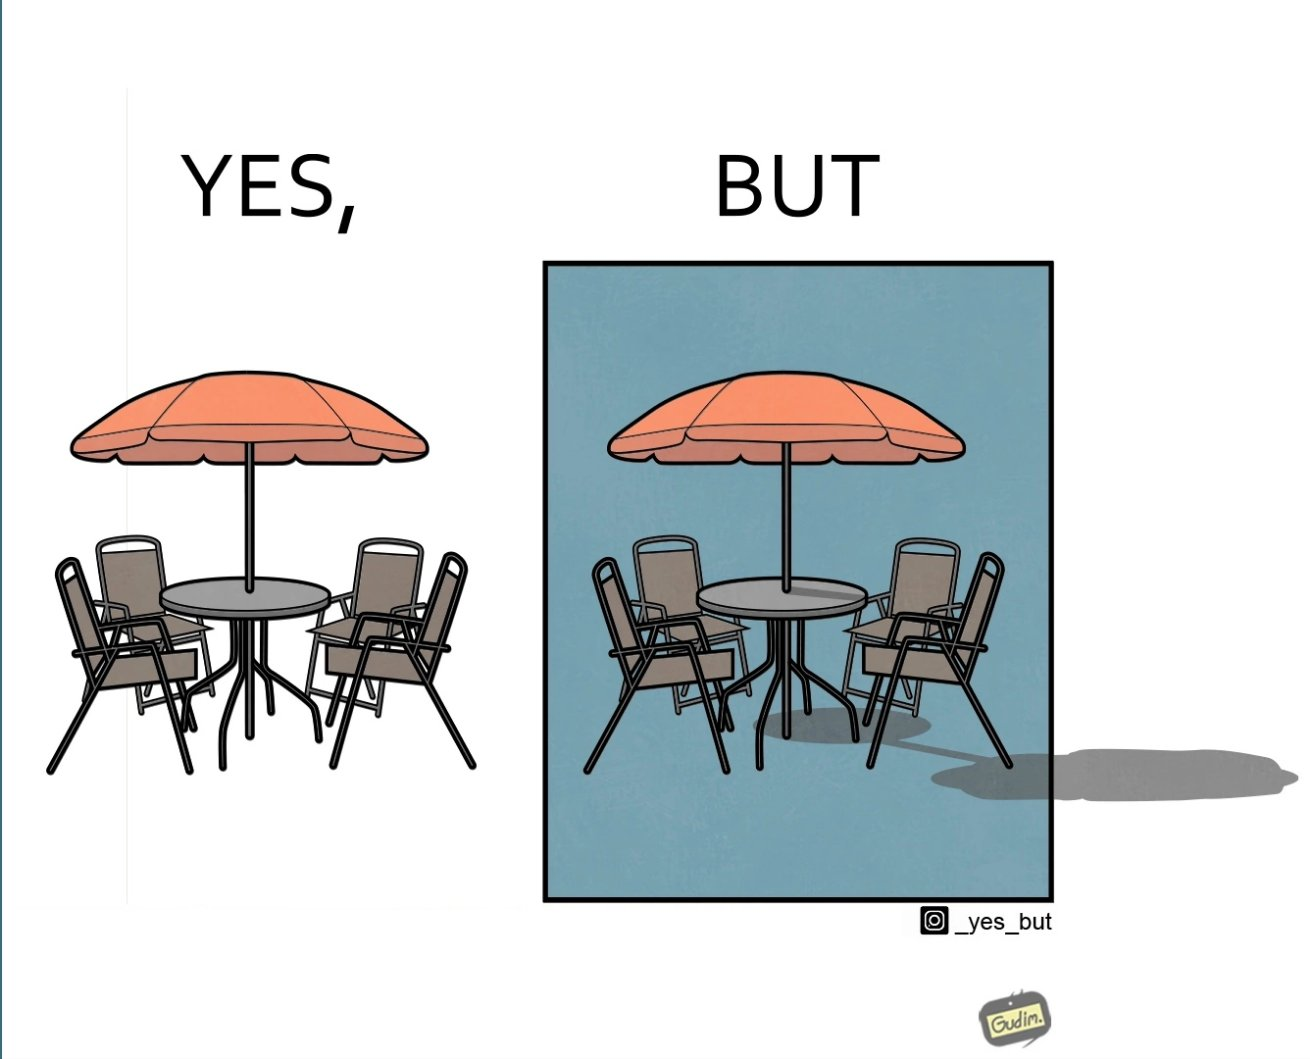Describe the content of this image. The image is ironical, as the umbrella is meant to provide shadow in the area where the chairs are present, but due to the orientation of the rays of the sun, all the chairs are in sunlight, and the umbrella is of no use in this situation. 